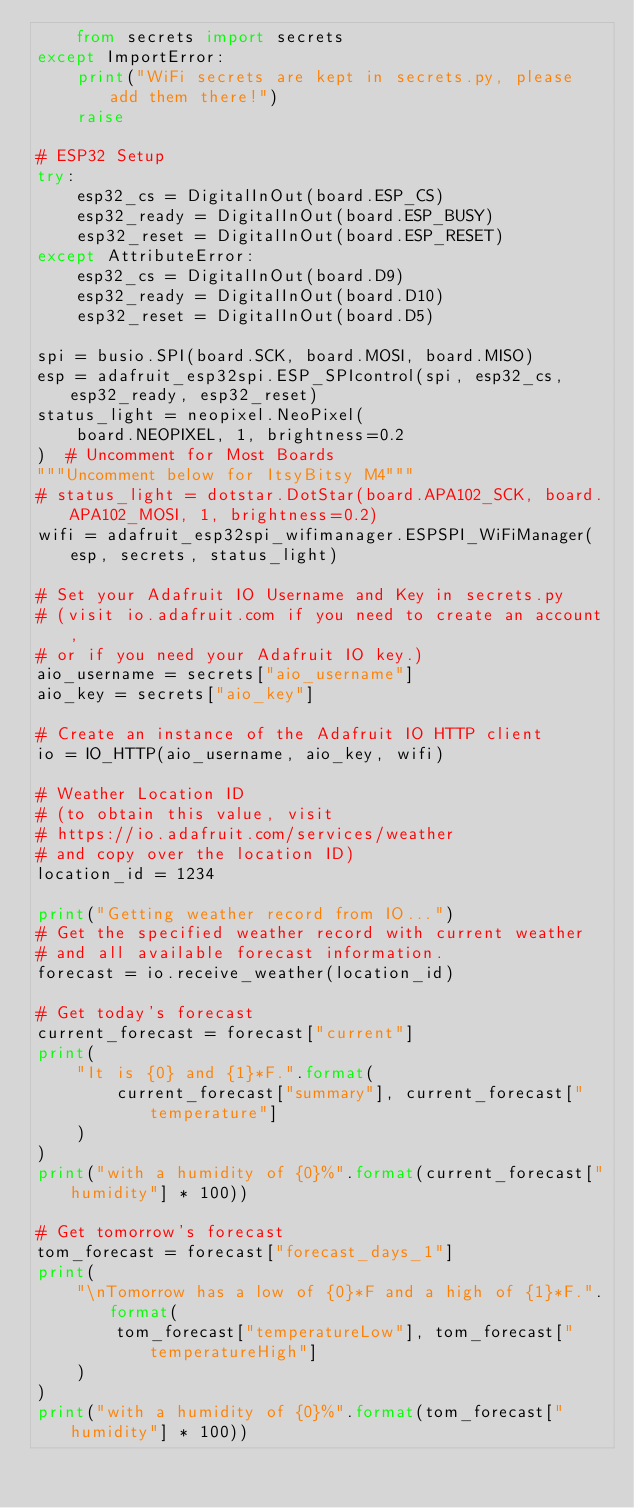<code> <loc_0><loc_0><loc_500><loc_500><_Python_>    from secrets import secrets
except ImportError:
    print("WiFi secrets are kept in secrets.py, please add them there!")
    raise

# ESP32 Setup
try:
    esp32_cs = DigitalInOut(board.ESP_CS)
    esp32_ready = DigitalInOut(board.ESP_BUSY)
    esp32_reset = DigitalInOut(board.ESP_RESET)
except AttributeError:
    esp32_cs = DigitalInOut(board.D9)
    esp32_ready = DigitalInOut(board.D10)
    esp32_reset = DigitalInOut(board.D5)

spi = busio.SPI(board.SCK, board.MOSI, board.MISO)
esp = adafruit_esp32spi.ESP_SPIcontrol(spi, esp32_cs, esp32_ready, esp32_reset)
status_light = neopixel.NeoPixel(
    board.NEOPIXEL, 1, brightness=0.2
)  # Uncomment for Most Boards
"""Uncomment below for ItsyBitsy M4"""
# status_light = dotstar.DotStar(board.APA102_SCK, board.APA102_MOSI, 1, brightness=0.2)
wifi = adafruit_esp32spi_wifimanager.ESPSPI_WiFiManager(esp, secrets, status_light)

# Set your Adafruit IO Username and Key in secrets.py
# (visit io.adafruit.com if you need to create an account,
# or if you need your Adafruit IO key.)
aio_username = secrets["aio_username"]
aio_key = secrets["aio_key"]

# Create an instance of the Adafruit IO HTTP client
io = IO_HTTP(aio_username, aio_key, wifi)

# Weather Location ID
# (to obtain this value, visit
# https://io.adafruit.com/services/weather
# and copy over the location ID)
location_id = 1234

print("Getting weather record from IO...")
# Get the specified weather record with current weather
# and all available forecast information.
forecast = io.receive_weather(location_id)

# Get today's forecast
current_forecast = forecast["current"]
print(
    "It is {0} and {1}*F.".format(
        current_forecast["summary"], current_forecast["temperature"]
    )
)
print("with a humidity of {0}%".format(current_forecast["humidity"] * 100))

# Get tomorrow's forecast
tom_forecast = forecast["forecast_days_1"]
print(
    "\nTomorrow has a low of {0}*F and a high of {1}*F.".format(
        tom_forecast["temperatureLow"], tom_forecast["temperatureHigh"]
    )
)
print("with a humidity of {0}%".format(tom_forecast["humidity"] * 100))
</code> 